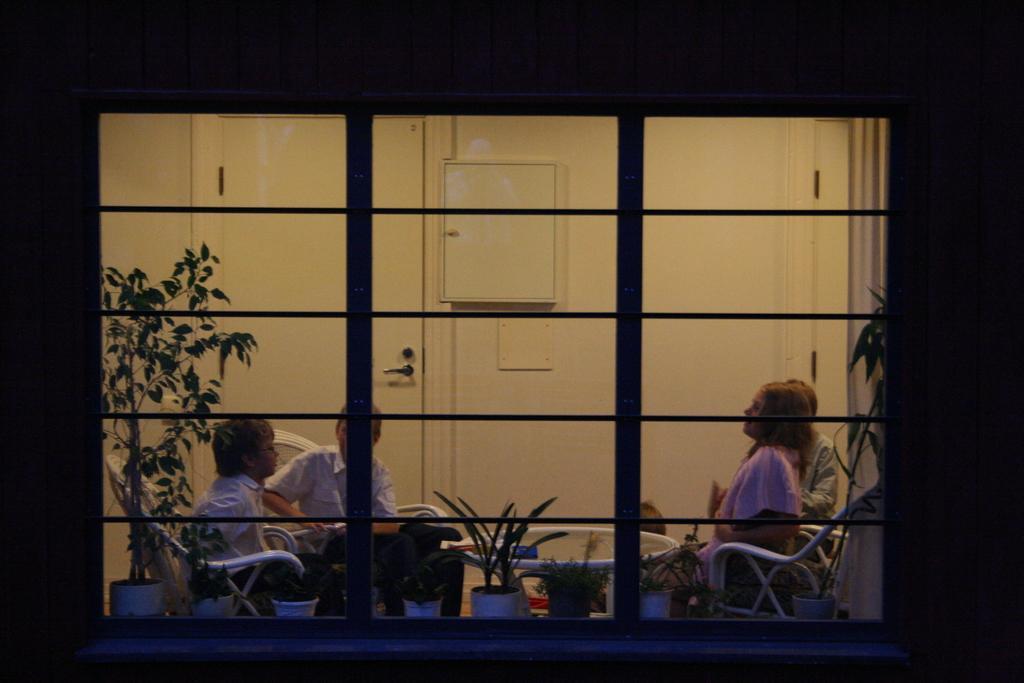In one or two sentences, can you explain what this image depicts? This picture seems to be clicked inside. In the foreground we can see the window and through the window we can see the houseplants, table and group of persons sitting on the chairs. In the background we can see the wall and a door and some other items. 